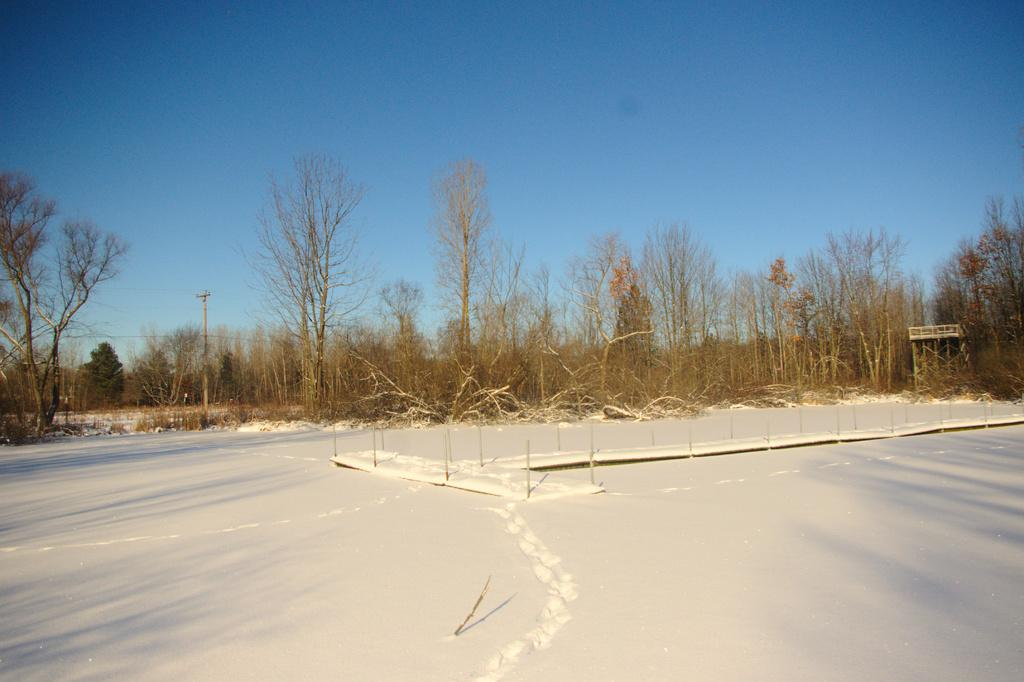What type of vegetation can be seen in the image? There are trees in the image. What structure is present in the image? There is a current pole in the image. What is the weather like in the image? There is snow visible in the image, indicating a cold or wintry environment. What color is the shirt worn by the tree in the image? There is no shirt present in the image, as trees are not capable of wearing clothing. How many fingers can be seen on the current pole in the image? There are no fingers present in the image, as current poles are inanimate objects and do not have body parts like fingers. 